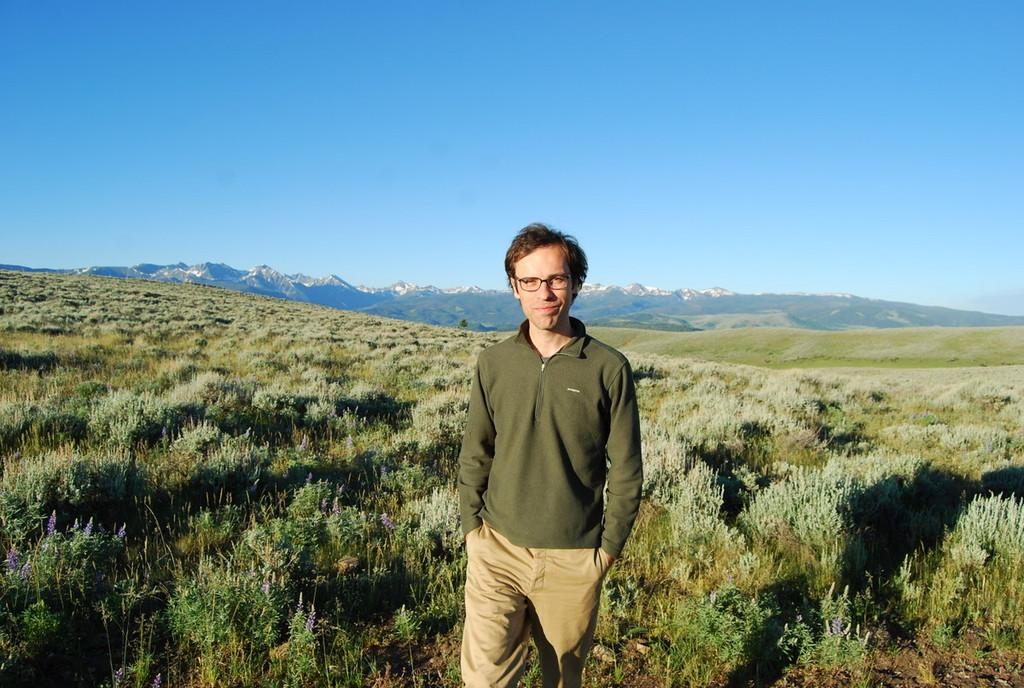What is the main subject of the image? There is a man standing in the image. What is the man wearing? The man is wearing clothes. What type of natural elements can be seen in the image? There are plants visible in the image. What part of the natural environment is visible in the image? The sky is visible in the image. Can you tell me how many bears are visible in the image? There are no bears present in the image; it features a man standing and plants in the background. What type of wash is the man using to clean his clothes in the image? There is no indication of any wash or cleaning activity in the image; the man is simply standing and wearing clothes. 